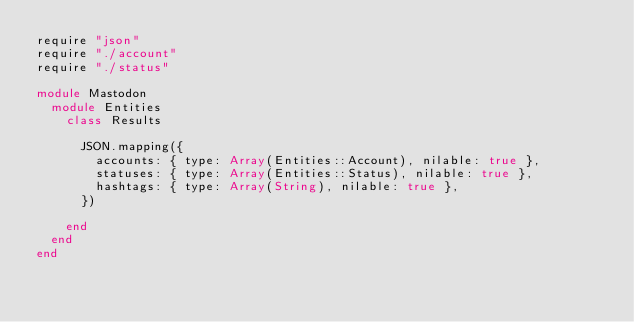Convert code to text. <code><loc_0><loc_0><loc_500><loc_500><_Crystal_>require "json"
require "./account"
require "./status"

module Mastodon
  module Entities
    class Results

      JSON.mapping({
        accounts: { type: Array(Entities::Account), nilable: true },
        statuses: { type: Array(Entities::Status), nilable: true },
        hashtags: { type: Array(String), nilable: true },
      })

    end
  end
end
</code> 